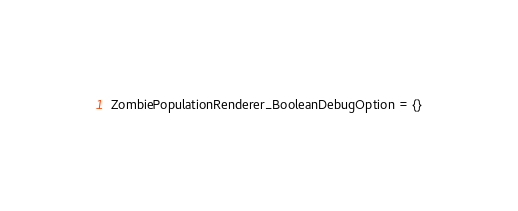<code> <loc_0><loc_0><loc_500><loc_500><_Lua_>ZombiePopulationRenderer_BooleanDebugOption = {}
</code> 